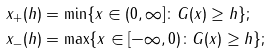Convert formula to latex. <formula><loc_0><loc_0><loc_500><loc_500>x _ { + } ( h ) & = \min \{ x \in ( 0 , \infty ] \colon G ( x ) \geq h \} ; \\ x _ { - } ( h ) & = \max \{ x \in [ - \infty , 0 ) \colon G ( x ) \geq h \} ;</formula> 